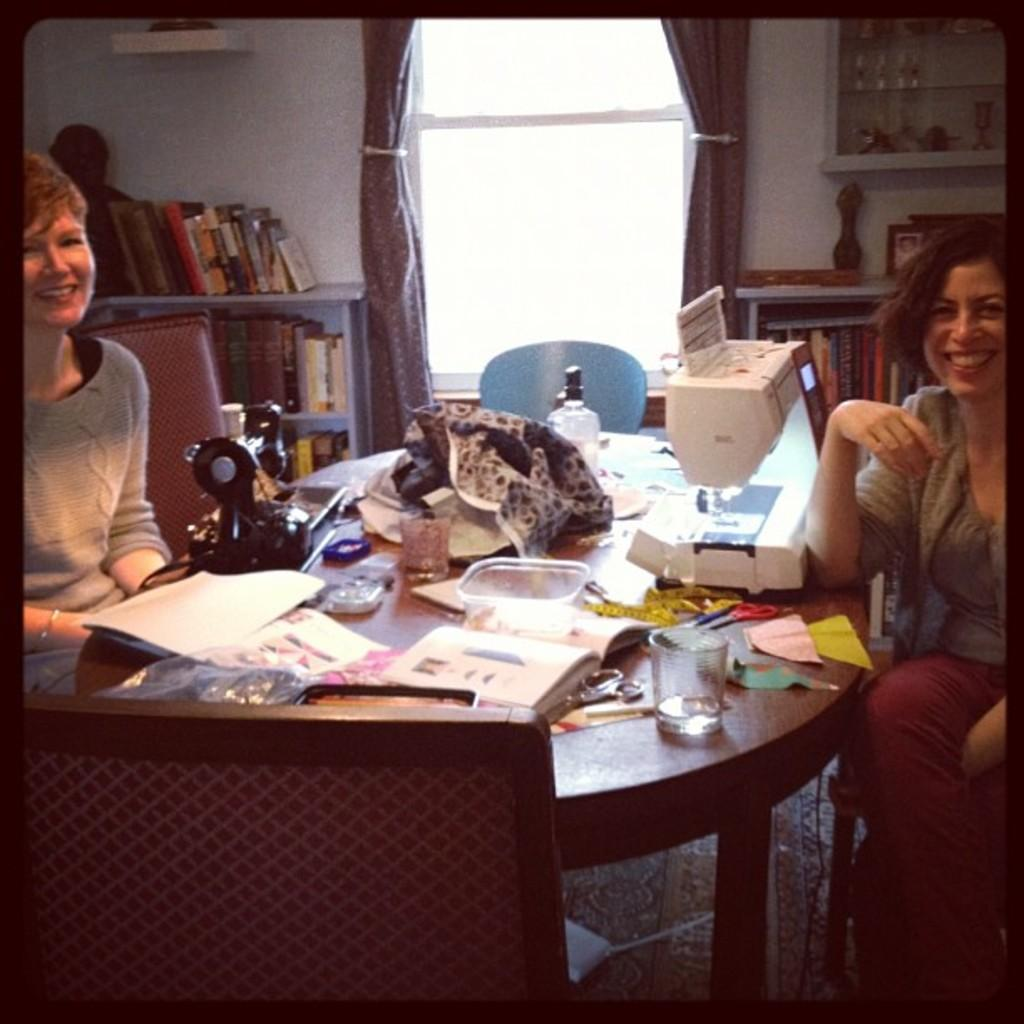How many women are in the image? There are two women in the image. What are the women sitting on? The women are seated on chairs. What is on the table in the image? There is a glass, papers, and a sewing machine on the table. What else can be seen in the image? There is a bookshelf in the image. What is covering the window? There are curtains on the window. What type of string is being used to sew the cream in the image? There is no string or cream present in the image. The sewing machine is on the table, but it is not being used, and there is no cream visible. 